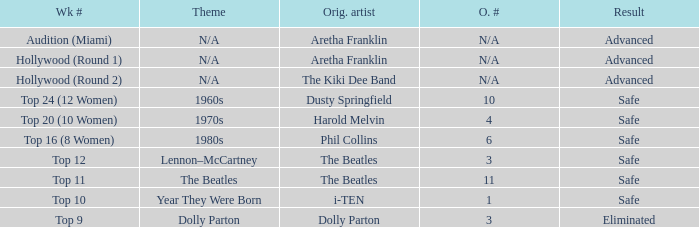What is the week number with Phil Collins as the original artist? Top 16 (8 Women). 